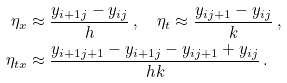Convert formula to latex. <formula><loc_0><loc_0><loc_500><loc_500>\eta _ { x } & \approx \frac { y _ { i + 1 j } - y _ { i j } } { h } \, , \quad \eta _ { t } \approx \frac { y _ { i j + 1 } - y _ { i j } } { k } \, , \\ \eta _ { t x } & \approx \frac { y _ { i + 1 j + 1 } - y _ { i + 1 j } - y _ { i j + 1 } + y _ { i j } } { h k } \, .</formula> 